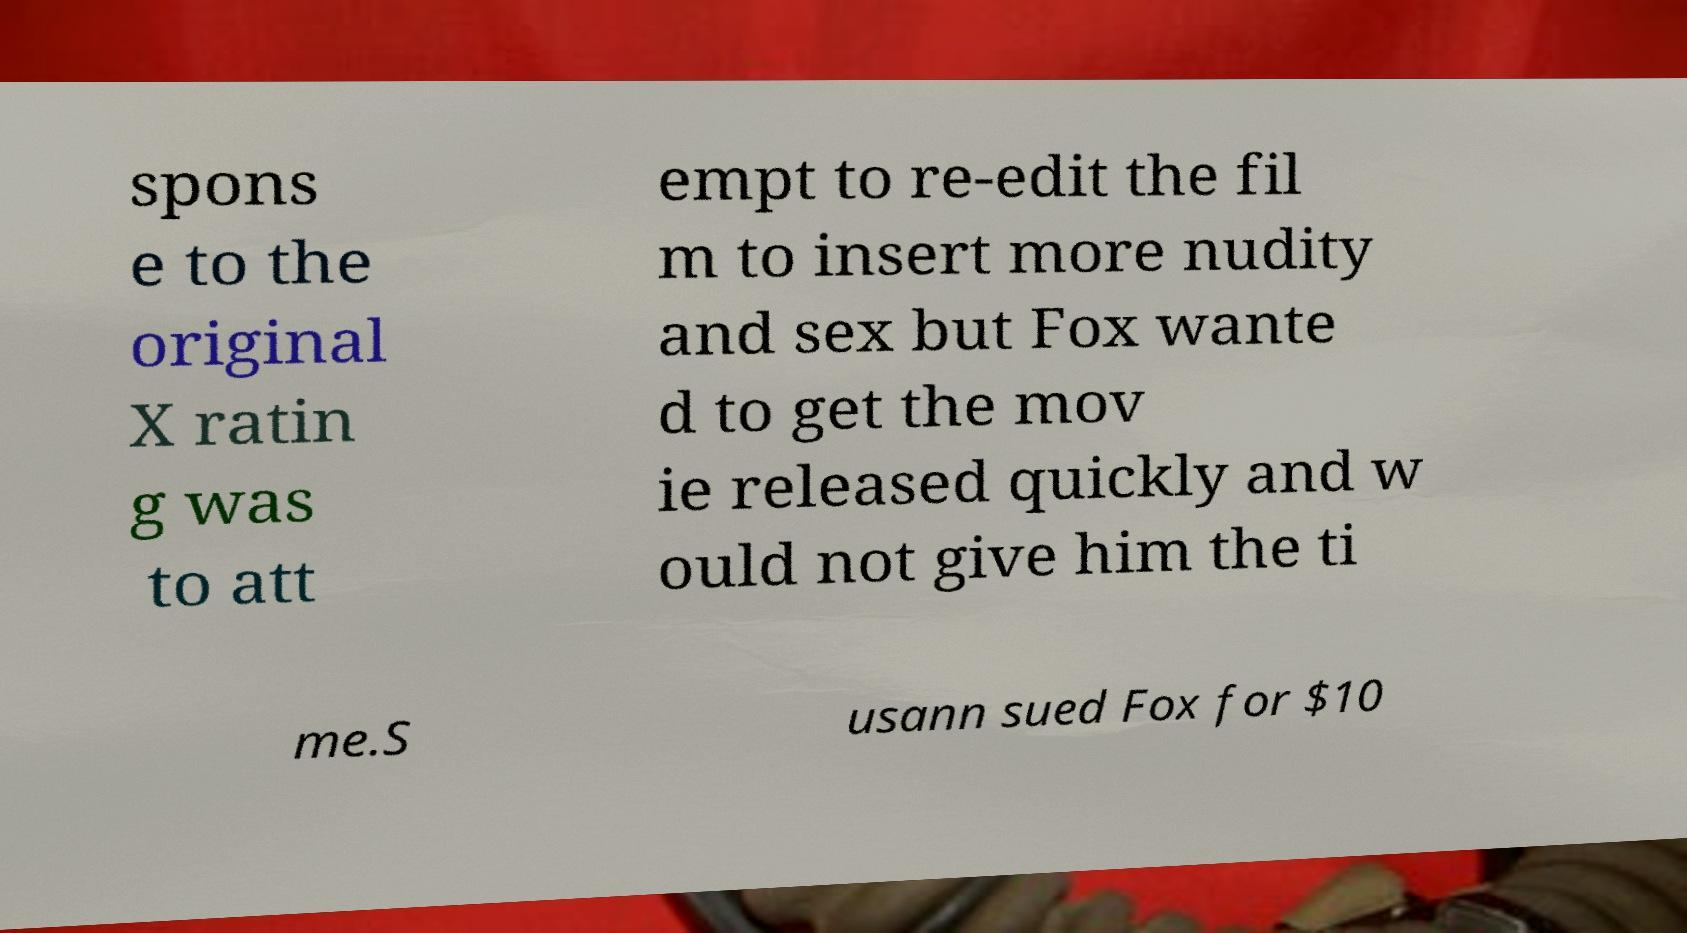Can you accurately transcribe the text from the provided image for me? spons e to the original X ratin g was to att empt to re-edit the fil m to insert more nudity and sex but Fox wante d to get the mov ie released quickly and w ould not give him the ti me.S usann sued Fox for $10 